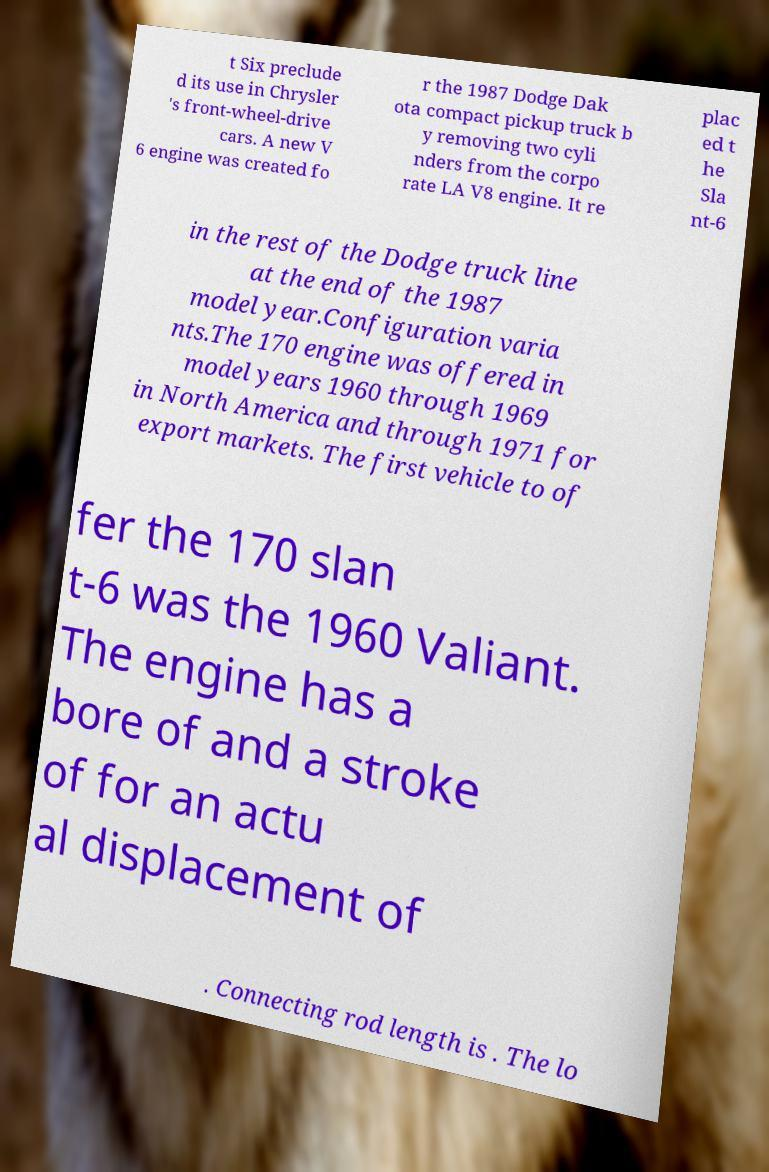For documentation purposes, I need the text within this image transcribed. Could you provide that? t Six preclude d its use in Chrysler 's front-wheel-drive cars. A new V 6 engine was created fo r the 1987 Dodge Dak ota compact pickup truck b y removing two cyli nders from the corpo rate LA V8 engine. It re plac ed t he Sla nt-6 in the rest of the Dodge truck line at the end of the 1987 model year.Configuration varia nts.The 170 engine was offered in model years 1960 through 1969 in North America and through 1971 for export markets. The first vehicle to of fer the 170 slan t-6 was the 1960 Valiant. The engine has a bore of and a stroke of for an actu al displacement of . Connecting rod length is . The lo 